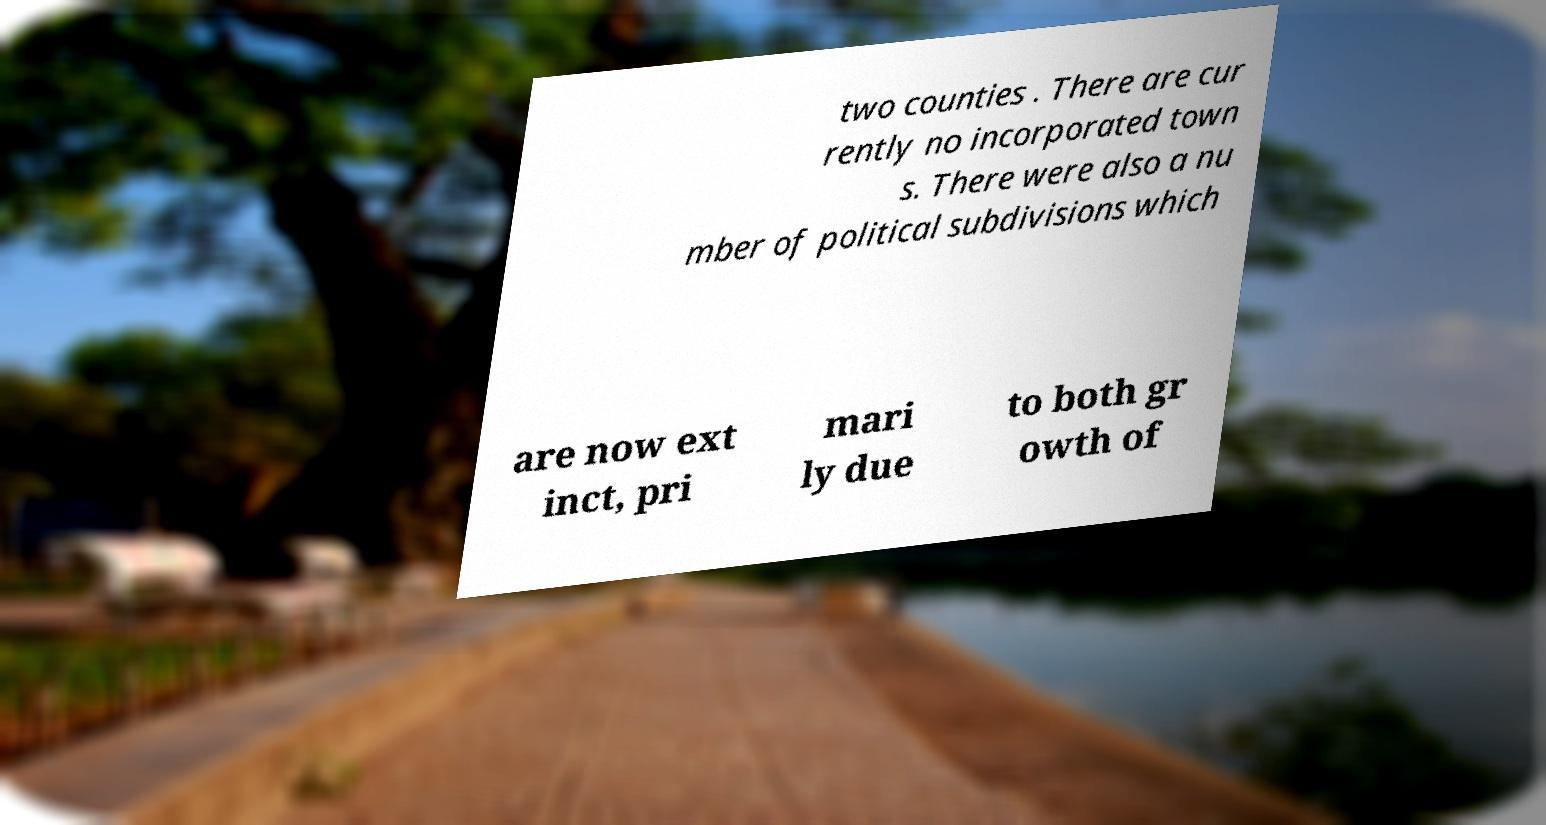For documentation purposes, I need the text within this image transcribed. Could you provide that? two counties . There are cur rently no incorporated town s. There were also a nu mber of political subdivisions which are now ext inct, pri mari ly due to both gr owth of 